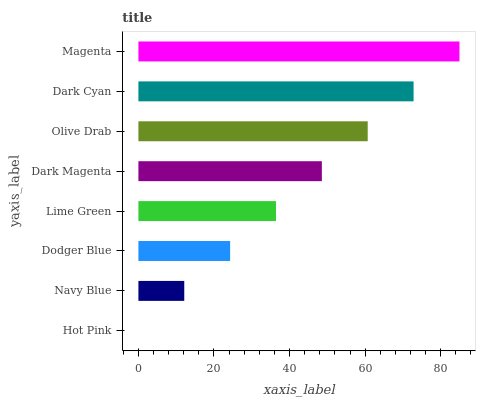Is Hot Pink the minimum?
Answer yes or no. Yes. Is Magenta the maximum?
Answer yes or no. Yes. Is Navy Blue the minimum?
Answer yes or no. No. Is Navy Blue the maximum?
Answer yes or no. No. Is Navy Blue greater than Hot Pink?
Answer yes or no. Yes. Is Hot Pink less than Navy Blue?
Answer yes or no. Yes. Is Hot Pink greater than Navy Blue?
Answer yes or no. No. Is Navy Blue less than Hot Pink?
Answer yes or no. No. Is Dark Magenta the high median?
Answer yes or no. Yes. Is Lime Green the low median?
Answer yes or no. Yes. Is Dark Cyan the high median?
Answer yes or no. No. Is Dark Magenta the low median?
Answer yes or no. No. 